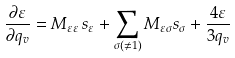Convert formula to latex. <formula><loc_0><loc_0><loc_500><loc_500>\frac { \partial \varepsilon } { \partial q _ { v } } = M _ { \varepsilon \varepsilon } \, s _ { \varepsilon } + \sum _ { \sigma ( \neq 1 ) } M _ { \varepsilon \sigma } s _ { \sigma } + \frac { 4 \varepsilon } { 3 q _ { v } }</formula> 